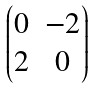<formula> <loc_0><loc_0><loc_500><loc_500>\begin{pmatrix} 0 & - 2 \\ 2 & 0 \end{pmatrix}</formula> 